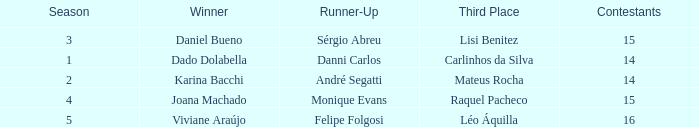Who was the winner when Mateus Rocha finished in 3rd place?  Karina Bacchi. 